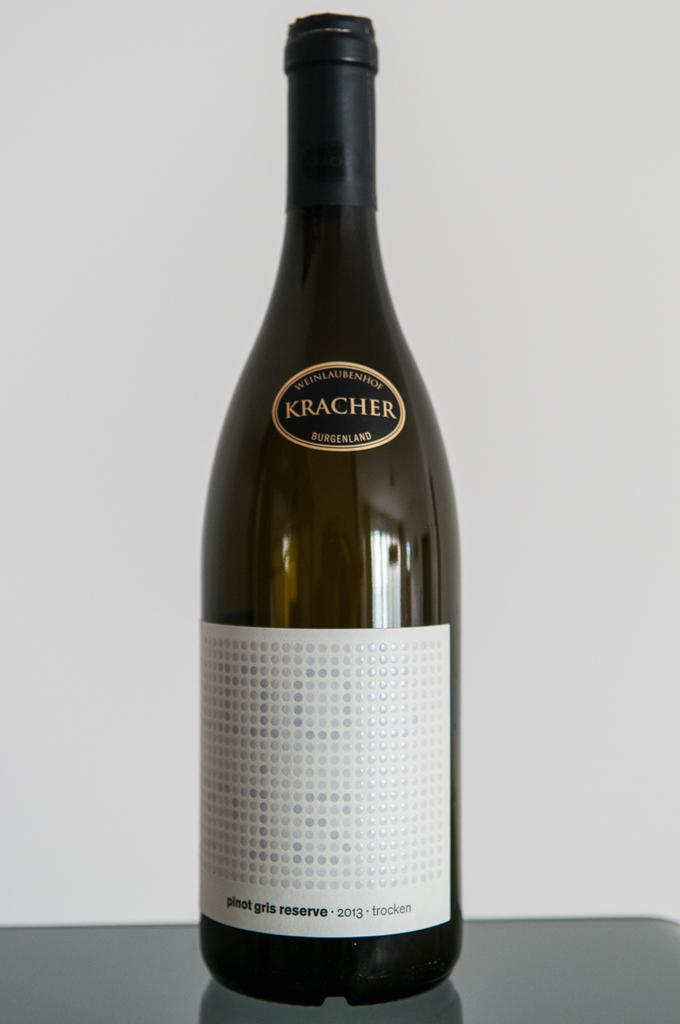<image>
Provide a brief description of the given image. A bottle of Kracher pinot gris reserve on a table. 